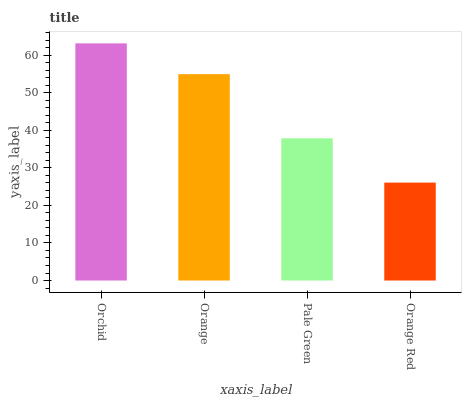Is Orange Red the minimum?
Answer yes or no. Yes. Is Orchid the maximum?
Answer yes or no. Yes. Is Orange the minimum?
Answer yes or no. No. Is Orange the maximum?
Answer yes or no. No. Is Orchid greater than Orange?
Answer yes or no. Yes. Is Orange less than Orchid?
Answer yes or no. Yes. Is Orange greater than Orchid?
Answer yes or no. No. Is Orchid less than Orange?
Answer yes or no. No. Is Orange the high median?
Answer yes or no. Yes. Is Pale Green the low median?
Answer yes or no. Yes. Is Orange Red the high median?
Answer yes or no. No. Is Orange the low median?
Answer yes or no. No. 